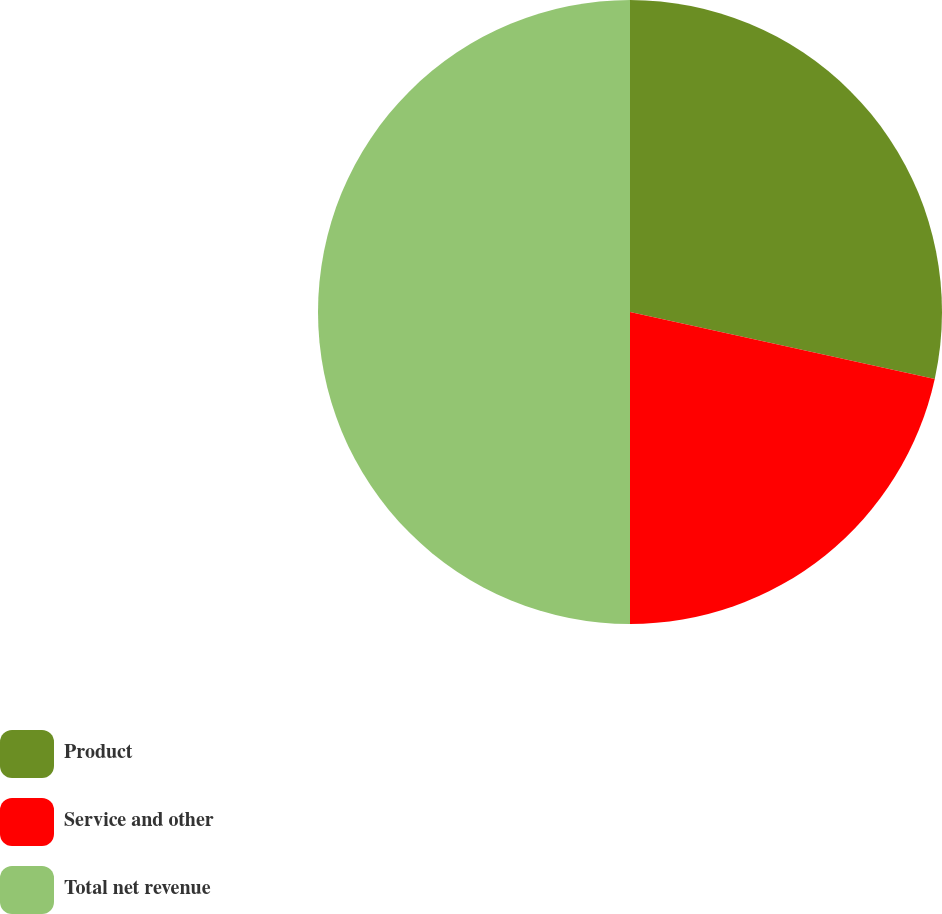Convert chart. <chart><loc_0><loc_0><loc_500><loc_500><pie_chart><fcel>Product<fcel>Service and other<fcel>Total net revenue<nl><fcel>28.44%<fcel>21.56%<fcel>50.0%<nl></chart> 